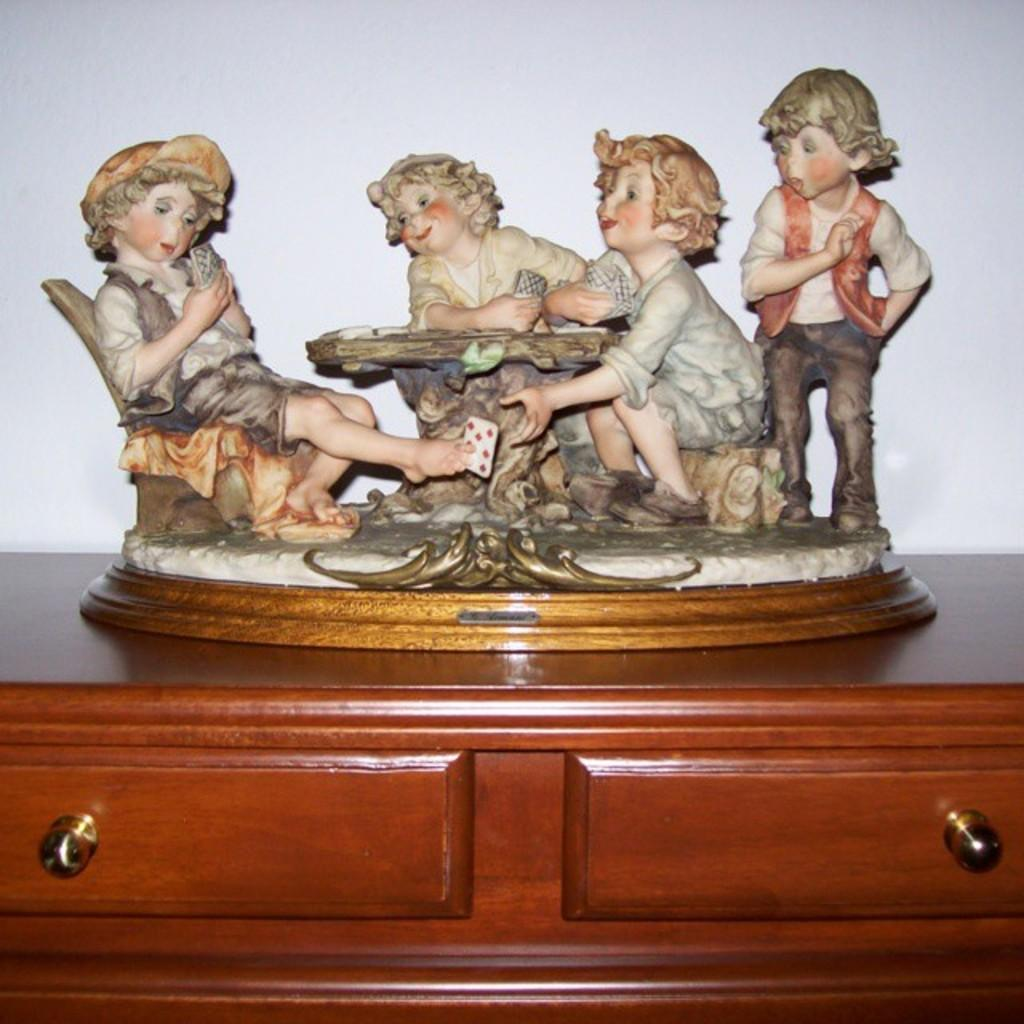What is the main subject of the image? The main subject of the image is a statue of kids sitting on a chair. Are there any other statues in the image? Yes, there are other statues of kids standing in the image. Where are the statues placed? The statues are kept on a cabinet. What type of toy can be seen being used by the kids in the image? There is no toy visible in the image, as the main subjects are statues of kids and not actual children. 